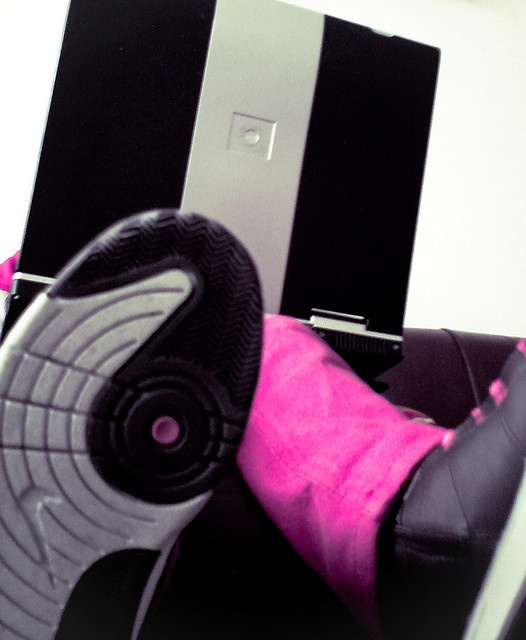Describe the objects in this image and their specific colors. I can see people in white, black, gray, darkgray, and violet tones, laptop in white, black, darkgray, lightgray, and ivory tones, and couch in white, black, purple, and gray tones in this image. 